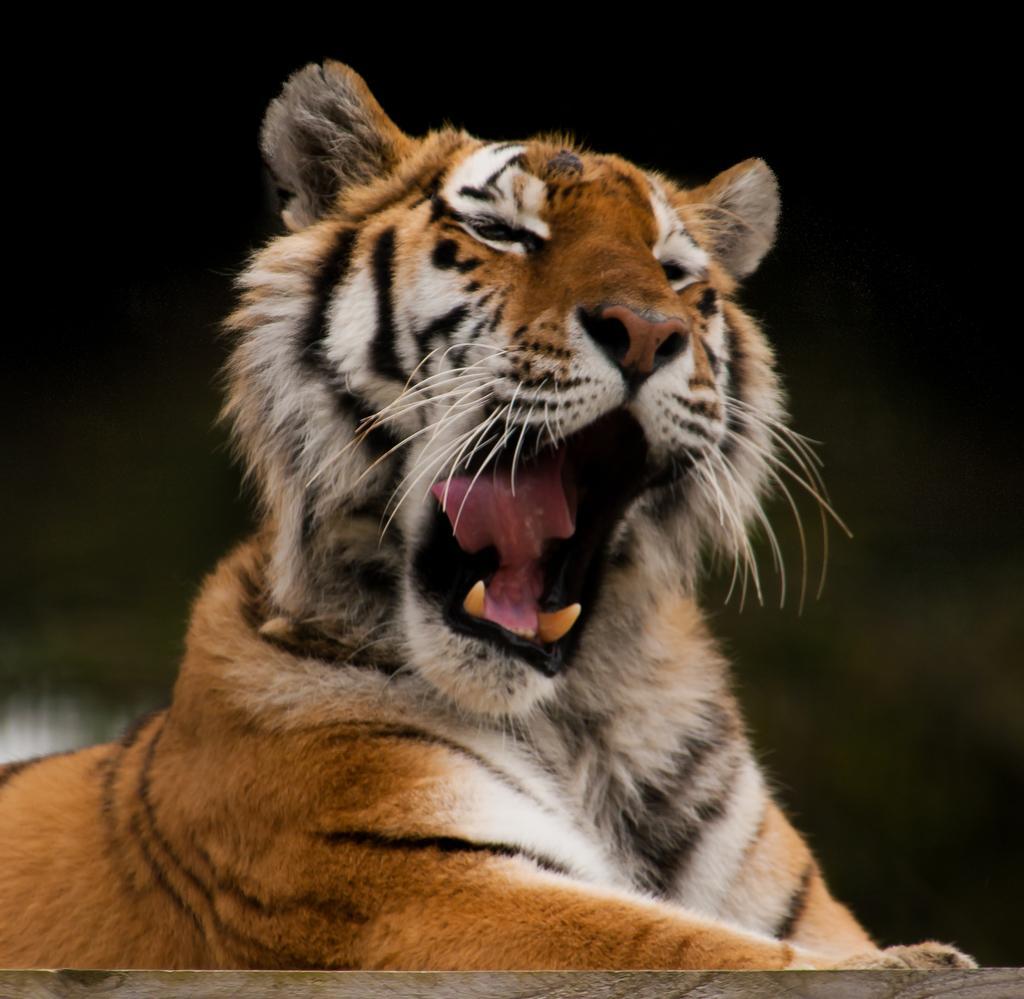In one or two sentences, can you explain what this image depicts? In the image there is a tiger,it is opening its mouth very wide and the background of the tiger is blur. 